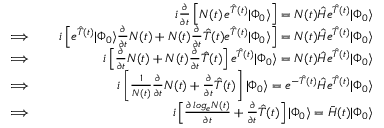Convert formula to latex. <formula><loc_0><loc_0><loc_500><loc_500>\begin{array} { r l r } & { i \frac { \partial } { \partial t } \left [ N ( t ) \, e ^ { \hat { T } ( t ) } | \Phi _ { 0 } \rangle \right ] = N ( t ) \hat { H } e ^ { \hat { T } ( t ) } | \Phi _ { 0 } \rangle } \\ { \implies } & { i \left [ e ^ { \hat { T } ( t ) } | \Phi _ { 0 } \rangle \frac { \partial } { \partial t } N ( t ) + N ( t ) \frac { \partial } { \partial t } \hat { T } ( t ) e ^ { \hat { T } ( t ) } | \Phi _ { 0 } \rangle \right ] = N ( t ) \hat { H } e ^ { \hat { T } ( t ) } | \Phi _ { 0 } \rangle } \\ { \implies } & { i \left [ \frac { \partial } { \partial t } N ( t ) + N ( t ) \frac { \partial } { \partial t } \hat { T } ( t ) \right ] e ^ { \hat { T } ( t ) } | \Phi _ { 0 } \rangle = N ( t ) \hat { H } e ^ { \hat { T } ( t ) } | \Phi _ { 0 } \rangle } \\ { \implies } & { i \left [ \frac { 1 } { N ( t ) } \frac { \partial } { \partial t } N ( t ) + \frac { \partial } { \partial t } \hat { T } ( t ) \right ] | \Phi _ { 0 } \rangle = e ^ { - \hat { T } ( t ) } \hat { H } e ^ { \hat { T } ( t ) } | \Phi _ { 0 } \rangle } \\ { \implies } & { i \left [ \frac { \partial \, \log _ { e } N ( t ) } { \partial t } + \frac { \partial } { \partial t } \hat { T } ( t ) \right ] | \Phi _ { 0 } \rangle = \bar { H } ( t ) | \Phi _ { 0 } \rangle } \end{array}</formula> 